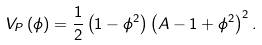<formula> <loc_0><loc_0><loc_500><loc_500>V _ { P } \left ( \phi \right ) = \frac { 1 } { 2 } \left ( 1 - \phi ^ { 2 } \right ) \left ( A - 1 + \phi ^ { 2 } \right ) ^ { 2 } .</formula> 